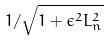<formula> <loc_0><loc_0><loc_500><loc_500>1 / \sqrt { 1 + \epsilon ^ { 2 } L _ { n } ^ { 2 } }</formula> 